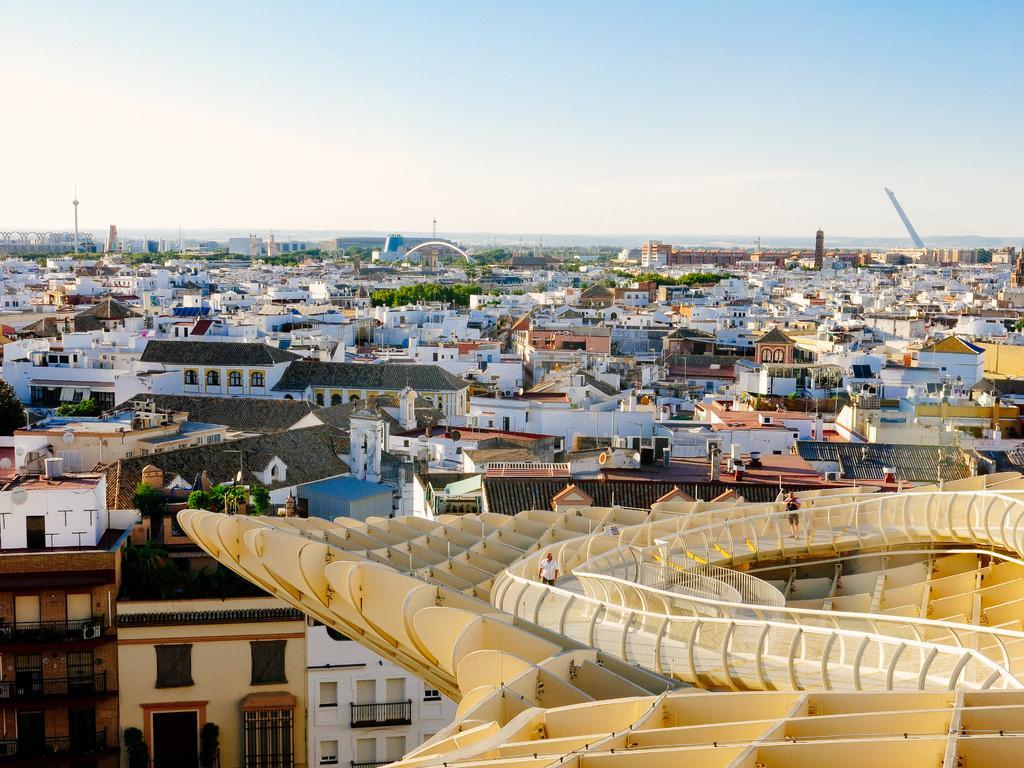In one or two sentences, can you explain what this image depicts? In this picture there is an object in the right corner which has two persons standing on it and there are buildings and trees in the background. 